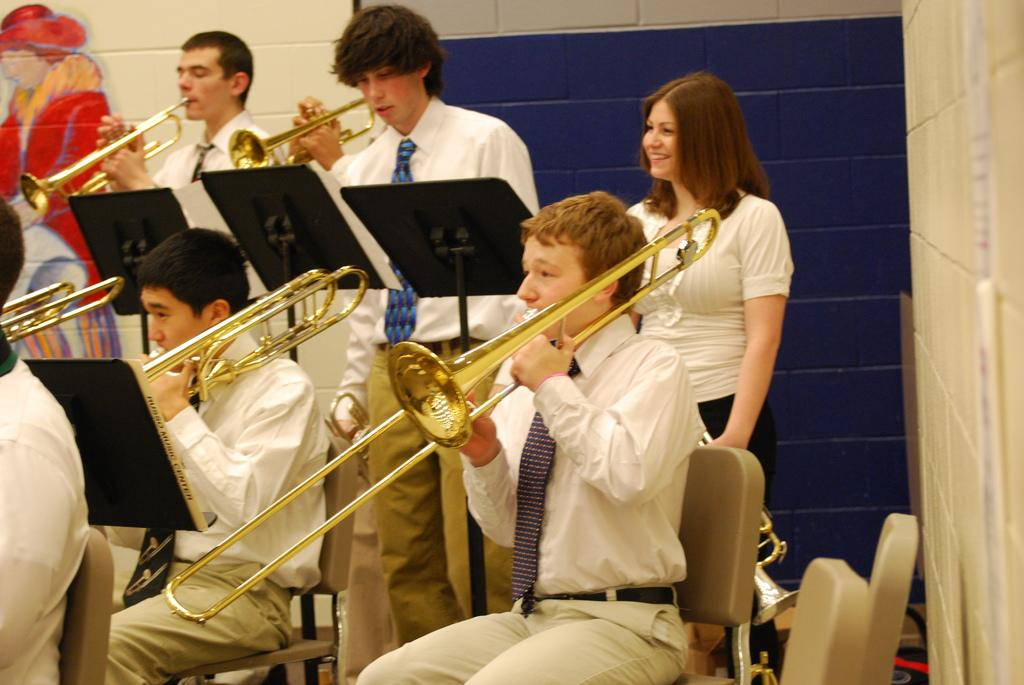Who is in the image? People are present in the image. What are the people wearing? The people are wearing white shirts. What are the people doing in the image? The people are playing saxophones. What can be seen supporting the instruments in the image? There are stands in the image. What is at the back of the scene? There is a wall at the back of the scene. What suggestion does the stranger make to the people in the image? There is no stranger present in the image, so no suggestion can be made. What type of skin is visible on the people in the image? The provided facts do not mention the skin of the people, so it cannot be determined from the image. 